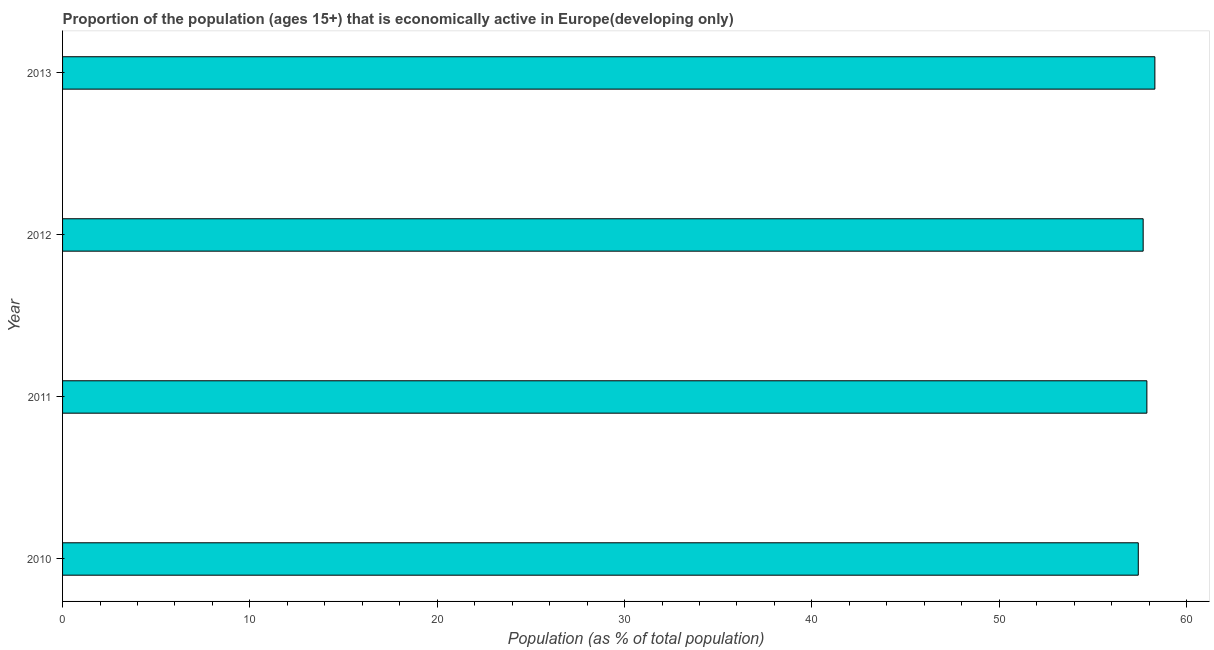Does the graph contain any zero values?
Make the answer very short. No. What is the title of the graph?
Keep it short and to the point. Proportion of the population (ages 15+) that is economically active in Europe(developing only). What is the label or title of the X-axis?
Your answer should be very brief. Population (as % of total population). What is the percentage of economically active population in 2013?
Your answer should be compact. 58.31. Across all years, what is the maximum percentage of economically active population?
Keep it short and to the point. 58.31. Across all years, what is the minimum percentage of economically active population?
Keep it short and to the point. 57.43. In which year was the percentage of economically active population maximum?
Ensure brevity in your answer.  2013. In which year was the percentage of economically active population minimum?
Provide a succinct answer. 2010. What is the sum of the percentage of economically active population?
Keep it short and to the point. 231.31. What is the difference between the percentage of economically active population in 2011 and 2013?
Your answer should be very brief. -0.43. What is the average percentage of economically active population per year?
Offer a very short reply. 57.83. What is the median percentage of economically active population?
Your response must be concise. 57.78. Do a majority of the years between 2011 and 2010 (inclusive) have percentage of economically active population greater than 44 %?
Keep it short and to the point. No. Is the percentage of economically active population in 2012 less than that in 2013?
Give a very brief answer. Yes. Is the difference between the percentage of economically active population in 2010 and 2011 greater than the difference between any two years?
Offer a terse response. No. What is the difference between the highest and the second highest percentage of economically active population?
Your answer should be very brief. 0.43. Is the sum of the percentage of economically active population in 2011 and 2013 greater than the maximum percentage of economically active population across all years?
Offer a terse response. Yes. What is the difference between the highest and the lowest percentage of economically active population?
Your answer should be very brief. 0.89. In how many years, is the percentage of economically active population greater than the average percentage of economically active population taken over all years?
Your answer should be compact. 2. How many bars are there?
Your answer should be compact. 4. Are the values on the major ticks of X-axis written in scientific E-notation?
Offer a terse response. No. What is the Population (as % of total population) of 2010?
Your answer should be compact. 57.43. What is the Population (as % of total population) in 2011?
Keep it short and to the point. 57.88. What is the Population (as % of total population) of 2012?
Give a very brief answer. 57.69. What is the Population (as % of total population) in 2013?
Offer a terse response. 58.31. What is the difference between the Population (as % of total population) in 2010 and 2011?
Give a very brief answer. -0.46. What is the difference between the Population (as % of total population) in 2010 and 2012?
Provide a succinct answer. -0.26. What is the difference between the Population (as % of total population) in 2010 and 2013?
Offer a very short reply. -0.89. What is the difference between the Population (as % of total population) in 2011 and 2012?
Make the answer very short. 0.2. What is the difference between the Population (as % of total population) in 2011 and 2013?
Your answer should be compact. -0.43. What is the difference between the Population (as % of total population) in 2012 and 2013?
Offer a very short reply. -0.63. What is the ratio of the Population (as % of total population) in 2010 to that in 2011?
Your answer should be very brief. 0.99. What is the ratio of the Population (as % of total population) in 2010 to that in 2012?
Give a very brief answer. 0.99. 